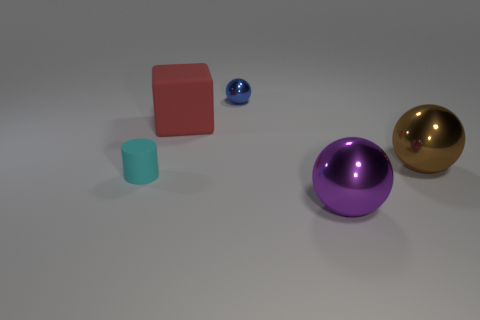Add 3 tiny cyan matte objects. How many objects exist? 8 Subtract all blocks. How many objects are left? 4 Subtract 1 cylinders. How many cylinders are left? 0 Subtract all cyan balls. Subtract all blue cylinders. How many balls are left? 3 Subtract all red cubes. How many brown cylinders are left? 0 Subtract all small blue metal cylinders. Subtract all purple shiny objects. How many objects are left? 4 Add 5 big brown things. How many big brown things are left? 6 Add 1 yellow metallic things. How many yellow metallic things exist? 1 Subtract all brown spheres. How many spheres are left? 2 Subtract all large brown metallic spheres. How many spheres are left? 2 